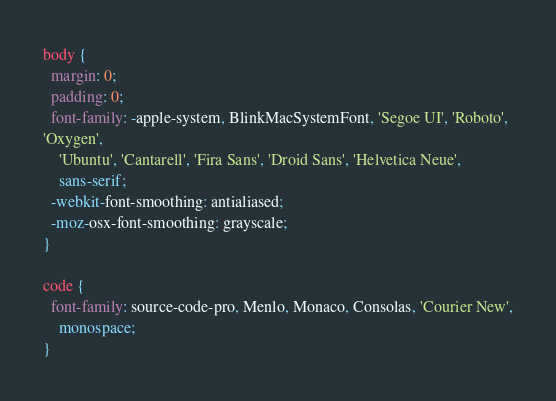Convert code to text. <code><loc_0><loc_0><loc_500><loc_500><_CSS_>body {
  margin: 0;
  padding: 0;
  font-family: -apple-system, BlinkMacSystemFont, 'Segoe UI', 'Roboto',
'Oxygen',
    'Ubuntu', 'Cantarell', 'Fira Sans', 'Droid Sans', 'Helvetica Neue',
    sans-serif;
  -webkit-font-smoothing: antialiased;
  -moz-osx-font-smoothing: grayscale;
}

code {
  font-family: source-code-pro, Menlo, Monaco, Consolas, 'Courier New',
    monospace;
}

</code> 